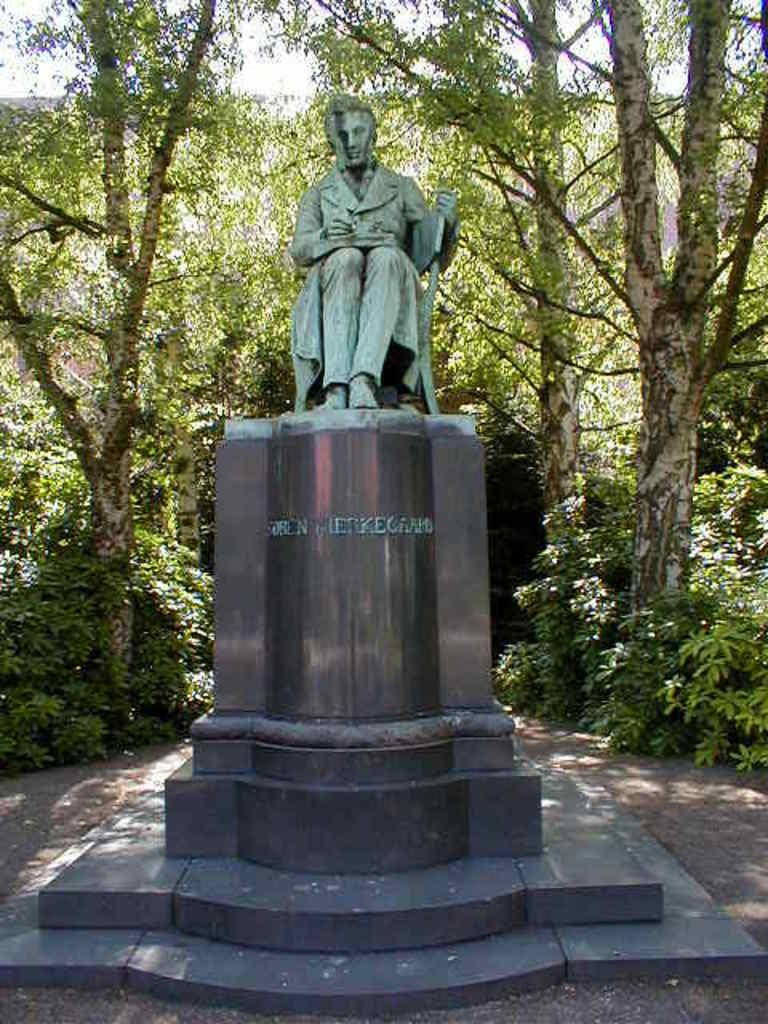What is the main subject of the image? There is a sculpture in the image. What can be seen in the background of the image? There are trees and the sky visible in the background of the image. What type of ink is being used to draw on the sculpture in the image? There is no ink or drawing on the sculpture in the image; it is a standalone sculpture. Is there a party happening near the sculpture in the image? There is no indication of a party or any gathering in the image; it only features the sculpture and the background. 